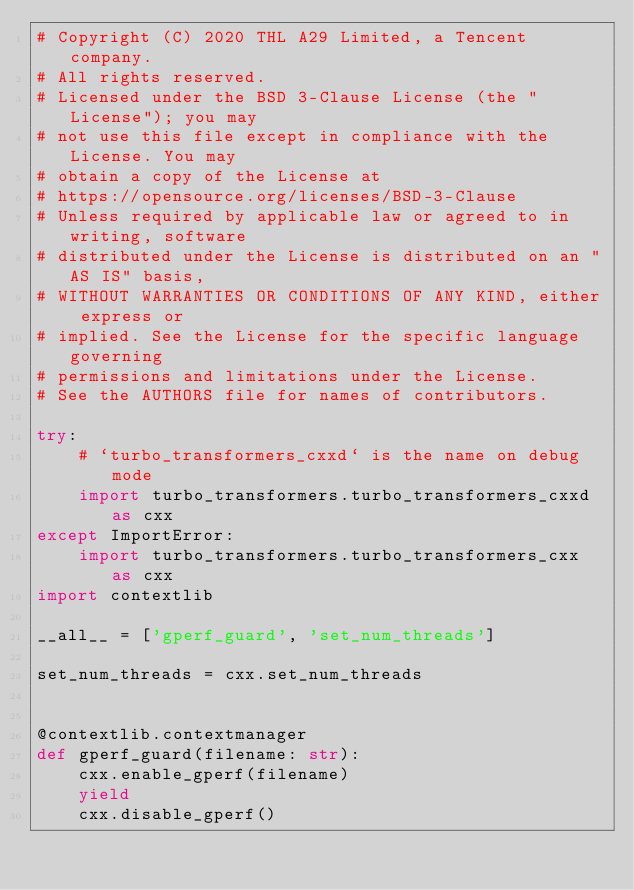Convert code to text. <code><loc_0><loc_0><loc_500><loc_500><_Python_># Copyright (C) 2020 THL A29 Limited, a Tencent company.
# All rights reserved.
# Licensed under the BSD 3-Clause License (the "License"); you may
# not use this file except in compliance with the License. You may
# obtain a copy of the License at
# https://opensource.org/licenses/BSD-3-Clause
# Unless required by applicable law or agreed to in writing, software
# distributed under the License is distributed on an "AS IS" basis,
# WITHOUT WARRANTIES OR CONDITIONS OF ANY KIND, either express or
# implied. See the License for the specific language governing
# permissions and limitations under the License.
# See the AUTHORS file for names of contributors.

try:
    # `turbo_transformers_cxxd` is the name on debug mode
    import turbo_transformers.turbo_transformers_cxxd as cxx
except ImportError:
    import turbo_transformers.turbo_transformers_cxx as cxx
import contextlib

__all__ = ['gperf_guard', 'set_num_threads']

set_num_threads = cxx.set_num_threads


@contextlib.contextmanager
def gperf_guard(filename: str):
    cxx.enable_gperf(filename)
    yield
    cxx.disable_gperf()
</code> 